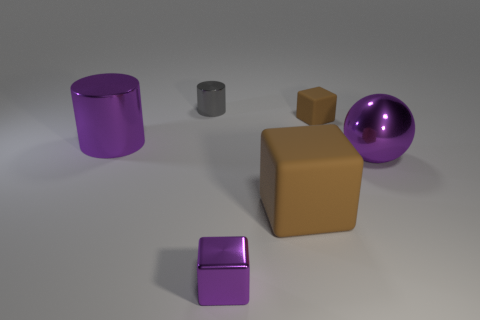Do the small brown matte object and the large matte thing have the same shape?
Provide a short and direct response. Yes. There is a purple shiny thing that is the same shape as the small rubber thing; what size is it?
Offer a terse response. Small. How many gray objects are the same material as the small purple cube?
Keep it short and to the point. 1. How many things are either big purple balls or purple metal things?
Provide a short and direct response. 3. Are there any small blocks behind the big purple thing on the left side of the small brown cube?
Ensure brevity in your answer.  Yes. Are there more small things behind the big block than small gray metal objects that are left of the large purple shiny cylinder?
Your response must be concise. Yes. There is a large thing that is the same color as the tiny rubber thing; what material is it?
Provide a short and direct response. Rubber. What number of things have the same color as the big metal ball?
Your response must be concise. 2. Does the big thing to the left of the tiny gray thing have the same color as the tiny metallic thing that is in front of the purple shiny cylinder?
Give a very brief answer. Yes. Are there any small blocks right of the small metal block?
Give a very brief answer. Yes. 